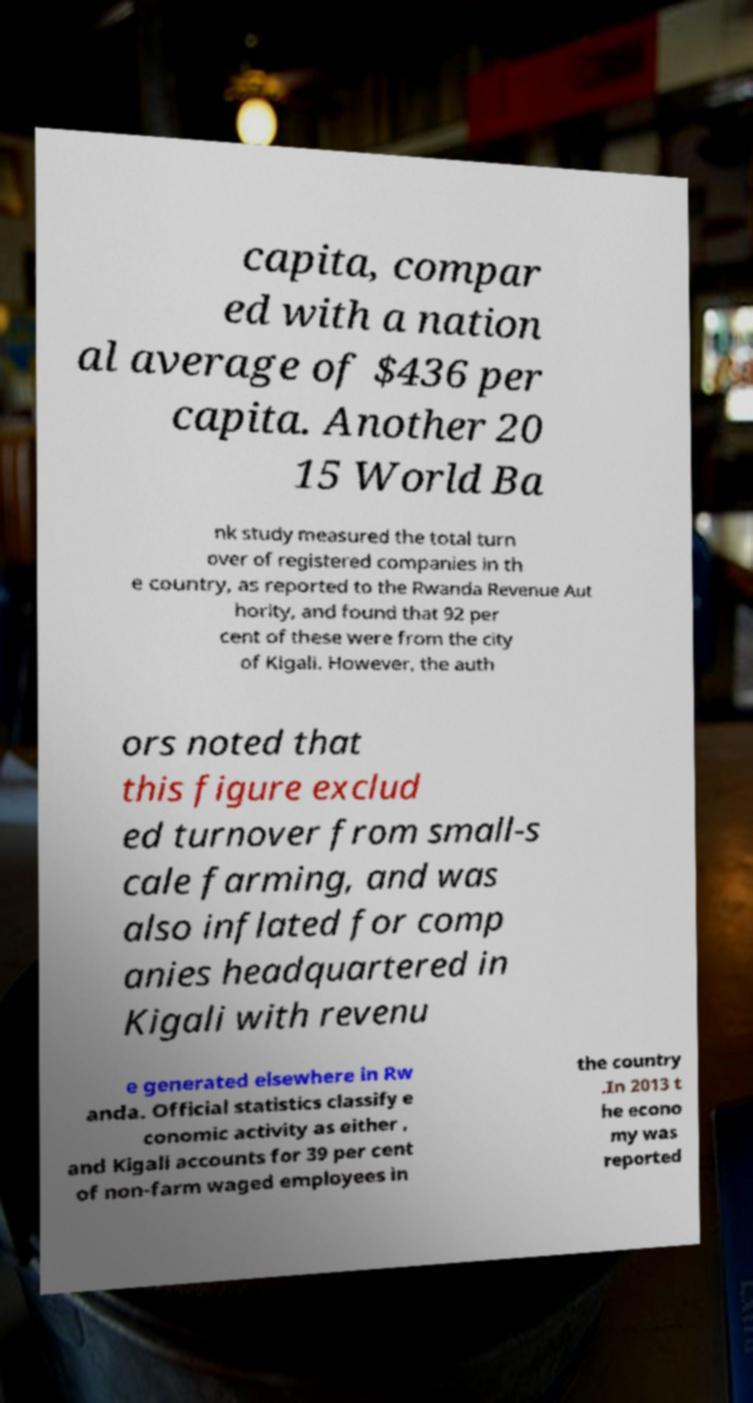I need the written content from this picture converted into text. Can you do that? capita, compar ed with a nation al average of $436 per capita. Another 20 15 World Ba nk study measured the total turn over of registered companies in th e country, as reported to the Rwanda Revenue Aut hority, and found that 92 per cent of these were from the city of Kigali. However, the auth ors noted that this figure exclud ed turnover from small-s cale farming, and was also inflated for comp anies headquartered in Kigali with revenu e generated elsewhere in Rw anda. Official statistics classify e conomic activity as either , and Kigali accounts for 39 per cent of non-farm waged employees in the country .In 2013 t he econo my was reported 